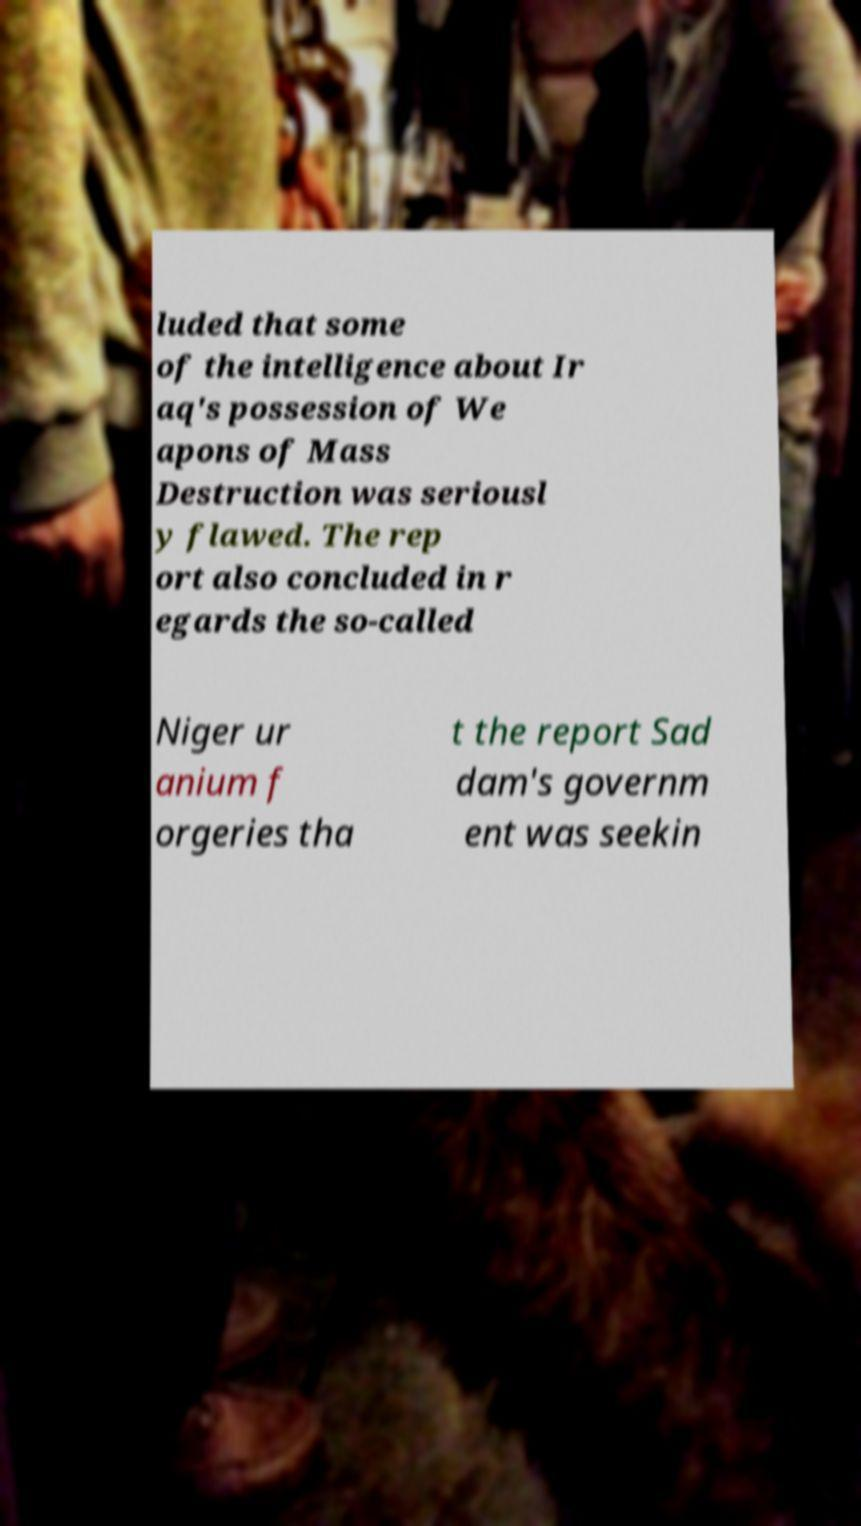I need the written content from this picture converted into text. Can you do that? luded that some of the intelligence about Ir aq's possession of We apons of Mass Destruction was seriousl y flawed. The rep ort also concluded in r egards the so-called Niger ur anium f orgeries tha t the report Sad dam's governm ent was seekin 